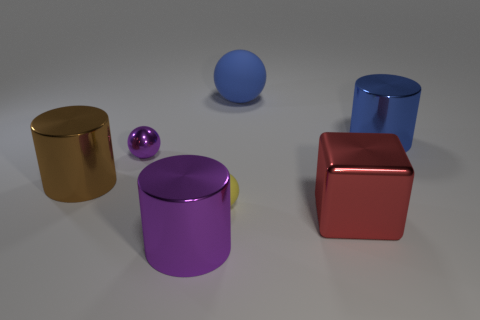Add 1 purple shiny objects. How many objects exist? 8 Subtract all cylinders. How many objects are left? 4 Subtract all yellow metallic objects. Subtract all big matte balls. How many objects are left? 6 Add 5 blue objects. How many blue objects are left? 7 Add 6 blue rubber objects. How many blue rubber objects exist? 7 Subtract 1 yellow balls. How many objects are left? 6 